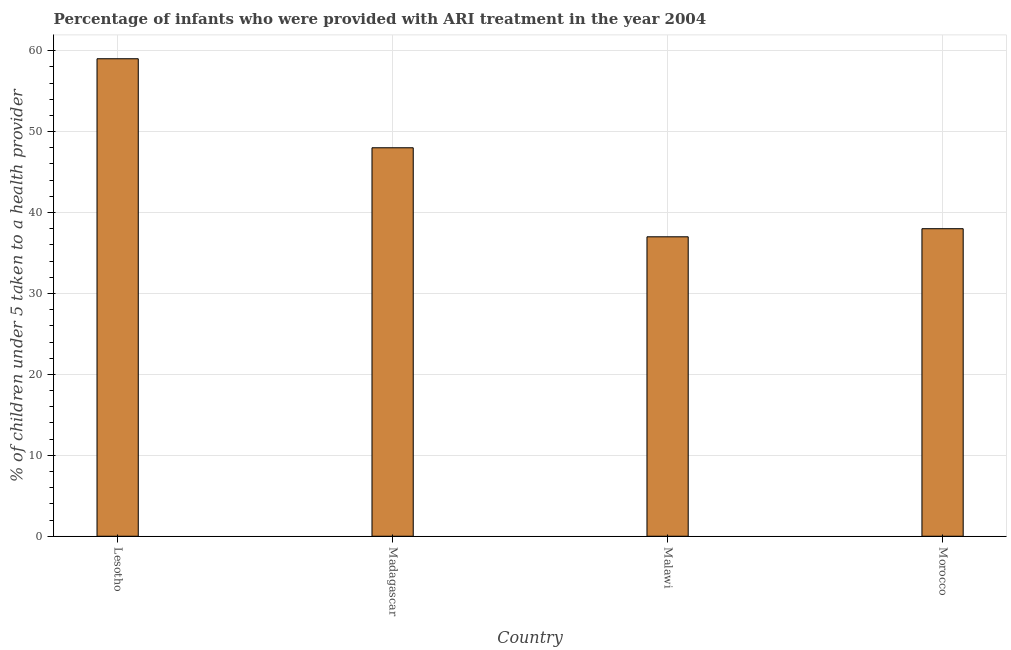Does the graph contain any zero values?
Give a very brief answer. No. Does the graph contain grids?
Make the answer very short. Yes. What is the title of the graph?
Ensure brevity in your answer.  Percentage of infants who were provided with ARI treatment in the year 2004. What is the label or title of the Y-axis?
Ensure brevity in your answer.  % of children under 5 taken to a health provider. Across all countries, what is the maximum percentage of children who were provided with ari treatment?
Offer a very short reply. 59. In which country was the percentage of children who were provided with ari treatment maximum?
Offer a terse response. Lesotho. In which country was the percentage of children who were provided with ari treatment minimum?
Your answer should be compact. Malawi. What is the sum of the percentage of children who were provided with ari treatment?
Your answer should be compact. 182. What is the average percentage of children who were provided with ari treatment per country?
Your response must be concise. 45.5. What is the median percentage of children who were provided with ari treatment?
Provide a succinct answer. 43. In how many countries, is the percentage of children who were provided with ari treatment greater than 6 %?
Provide a short and direct response. 4. What is the ratio of the percentage of children who were provided with ari treatment in Lesotho to that in Madagascar?
Your answer should be compact. 1.23. Is the difference between the percentage of children who were provided with ari treatment in Madagascar and Morocco greater than the difference between any two countries?
Your response must be concise. No. Is the sum of the percentage of children who were provided with ari treatment in Madagascar and Malawi greater than the maximum percentage of children who were provided with ari treatment across all countries?
Your answer should be very brief. Yes. What is the difference between the highest and the lowest percentage of children who were provided with ari treatment?
Offer a very short reply. 22. How many bars are there?
Give a very brief answer. 4. Are all the bars in the graph horizontal?
Offer a very short reply. No. What is the % of children under 5 taken to a health provider of Madagascar?
Give a very brief answer. 48. What is the % of children under 5 taken to a health provider in Malawi?
Keep it short and to the point. 37. What is the difference between the % of children under 5 taken to a health provider in Lesotho and Madagascar?
Keep it short and to the point. 11. What is the difference between the % of children under 5 taken to a health provider in Lesotho and Malawi?
Your answer should be compact. 22. What is the difference between the % of children under 5 taken to a health provider in Lesotho and Morocco?
Give a very brief answer. 21. What is the difference between the % of children under 5 taken to a health provider in Madagascar and Malawi?
Ensure brevity in your answer.  11. What is the difference between the % of children under 5 taken to a health provider in Madagascar and Morocco?
Offer a very short reply. 10. What is the ratio of the % of children under 5 taken to a health provider in Lesotho to that in Madagascar?
Provide a succinct answer. 1.23. What is the ratio of the % of children under 5 taken to a health provider in Lesotho to that in Malawi?
Make the answer very short. 1.59. What is the ratio of the % of children under 5 taken to a health provider in Lesotho to that in Morocco?
Offer a terse response. 1.55. What is the ratio of the % of children under 5 taken to a health provider in Madagascar to that in Malawi?
Give a very brief answer. 1.3. What is the ratio of the % of children under 5 taken to a health provider in Madagascar to that in Morocco?
Give a very brief answer. 1.26. What is the ratio of the % of children under 5 taken to a health provider in Malawi to that in Morocco?
Your answer should be very brief. 0.97. 